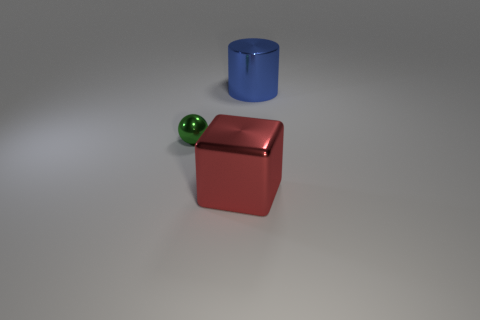Add 2 small green shiny objects. How many objects exist? 5 Subtract all red metal things. Subtract all tiny green spheres. How many objects are left? 1 Add 2 small shiny objects. How many small shiny objects are left? 3 Add 3 red metallic things. How many red metallic things exist? 4 Subtract 0 cyan cylinders. How many objects are left? 3 Subtract all spheres. How many objects are left? 2 